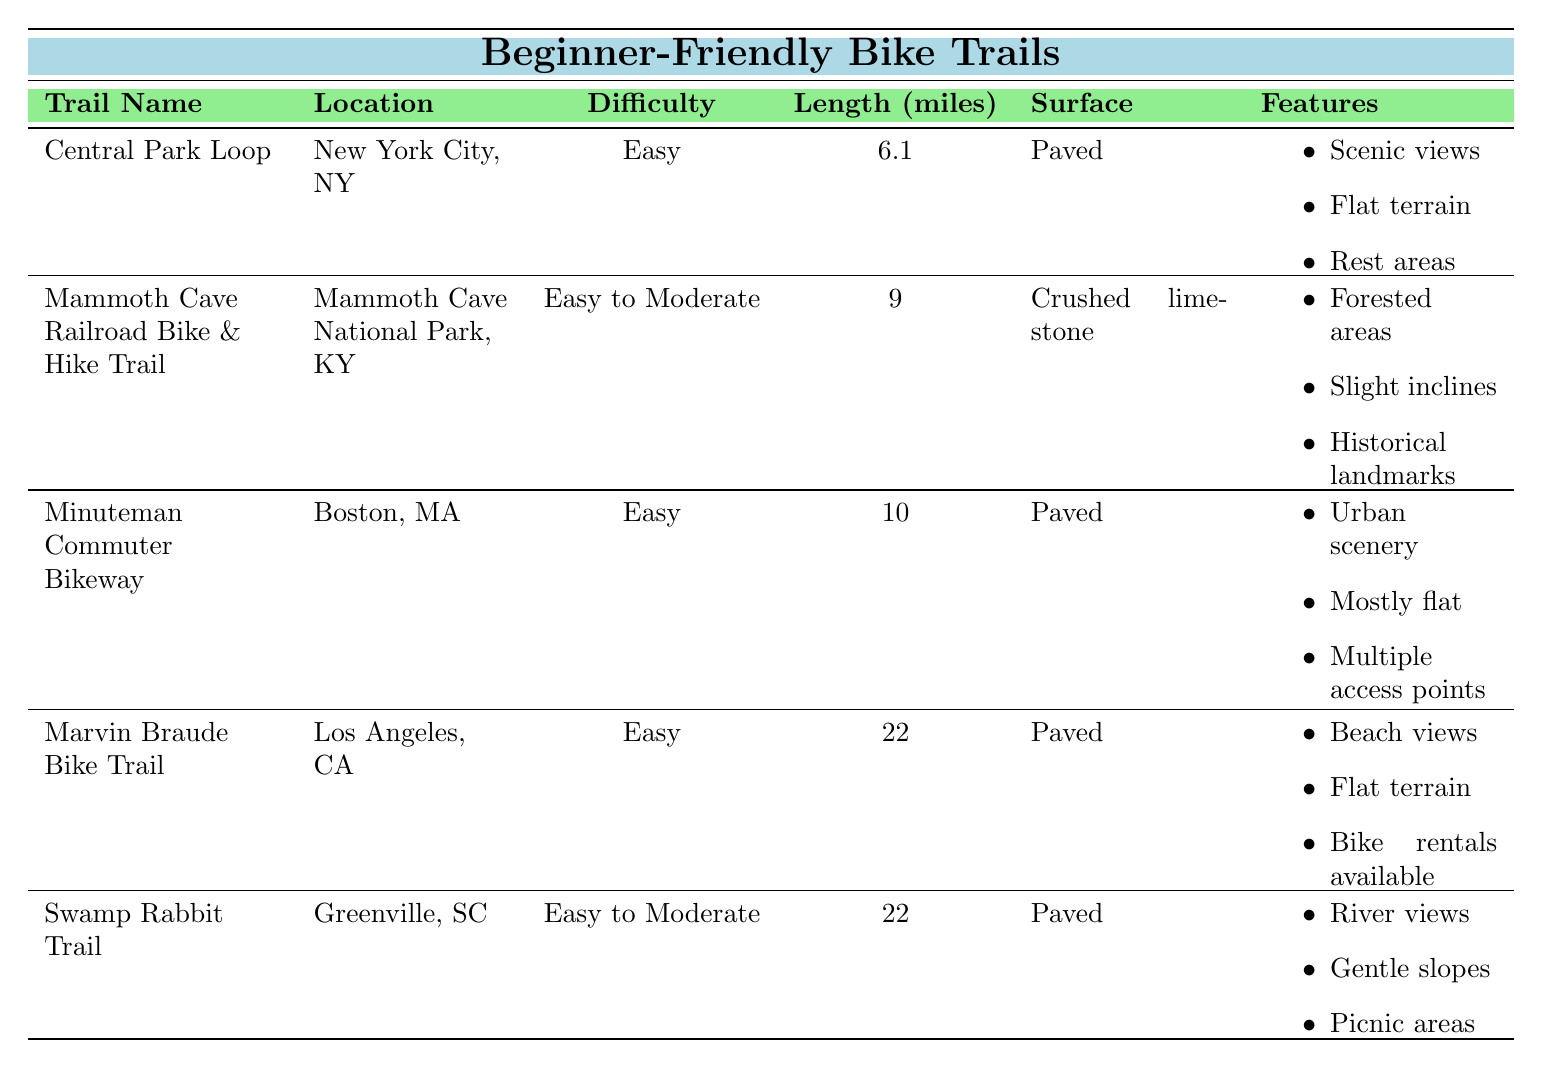What is the length of the Marvin Braude Bike Trail? The table lists various bike trails along with their lengths. For the Marvin Braude Bike Trail, the length is explicitly stated as 22 miles.
Answer: 22 miles Which trail is located in Greenville, SC? By scanning the "Location" column in the table, we can see that the Swamp Rabbit Trail is listed under Greenville, SC.
Answer: Swamp Rabbit Trail How many trails have an "Easy to Moderate" difficulty level? The table shows different difficulty levels for each trail. By counting, we find that there are 2 trails with "Easy to Moderate" difficulty: Mammoth Cave Railroad Bike & Hike Trail and Swamp Rabbit Trail.
Answer: 2 What is the total length of all the trails? Adding the lengths of each trail: 6.1 + 9 + 10 + 22 + 22 = 69.1 miles gives the total length of all trails listed in the table.
Answer: 69.1 miles Which trail has the most features listed? The features for each trail are listed as bullet points. The Marvin Braude Bike Trail has 3 features while all others have 3 as well. No one trail has more features than the others, making them equal in that aspect.
Answer: All have equal features Is the Central Park Loop trail paved or gravel? The "Surface" column clearly indicates that the Central Park Loop trail's surface is "Paved".
Answer: Paved What difficulty level does the Minuteman Commuter Bikeway have? The table specifies that the Minuteman Commuter Bikeway's difficulty level is "Easy".
Answer: Easy Which trail has the longest length? Comparing the lengths, both Marvin Braude Bike Trail and Swamp Rabbit Trail are tied at 22 miles, making them the longest.
Answer: Marvin Braude Bike Trail and Swamp Rabbit Trail Do any of the trails have bike rentals available? The features section for the Marvin Braude Bike Trail explicitly mentions "Bike rentals available", indicating this option is present only for that trail.
Answer: Yes, for Marvin Braude Bike Trail What features are shared by all trails? The features for each trail vary. By reviewing the features listed, there are no features that are found in every trail.
Answer: None 